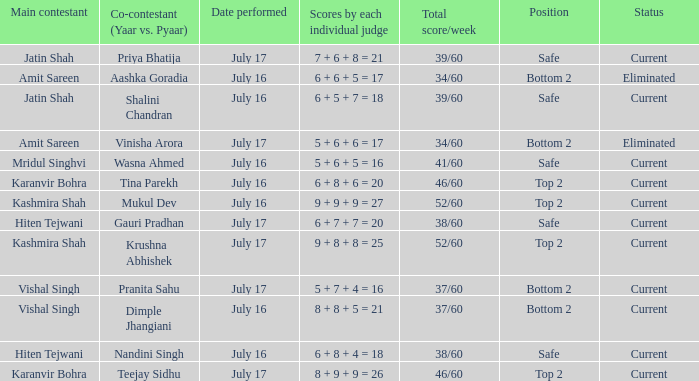What position did Pranita Sahu's team get? Bottom 2. 